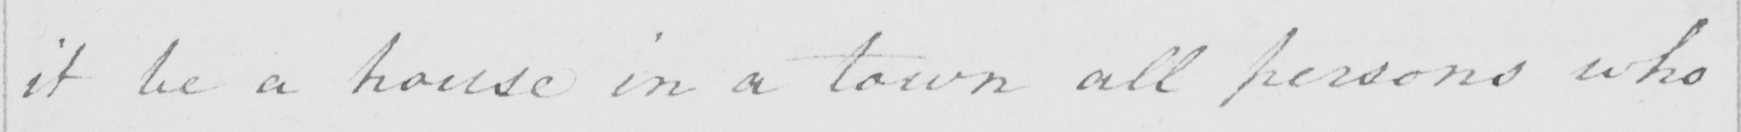Can you tell me what this handwritten text says? it be a house in a town all persons who 